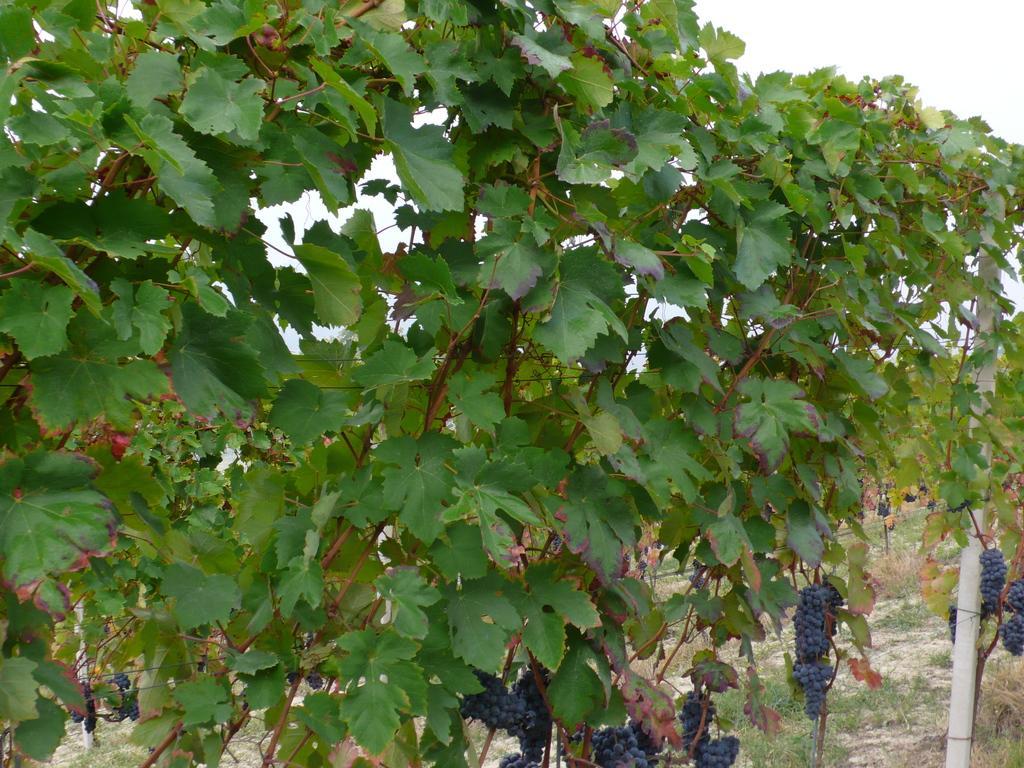Could you give a brief overview of what you see in this image? In this picture there is grape vine in the center of the image. 